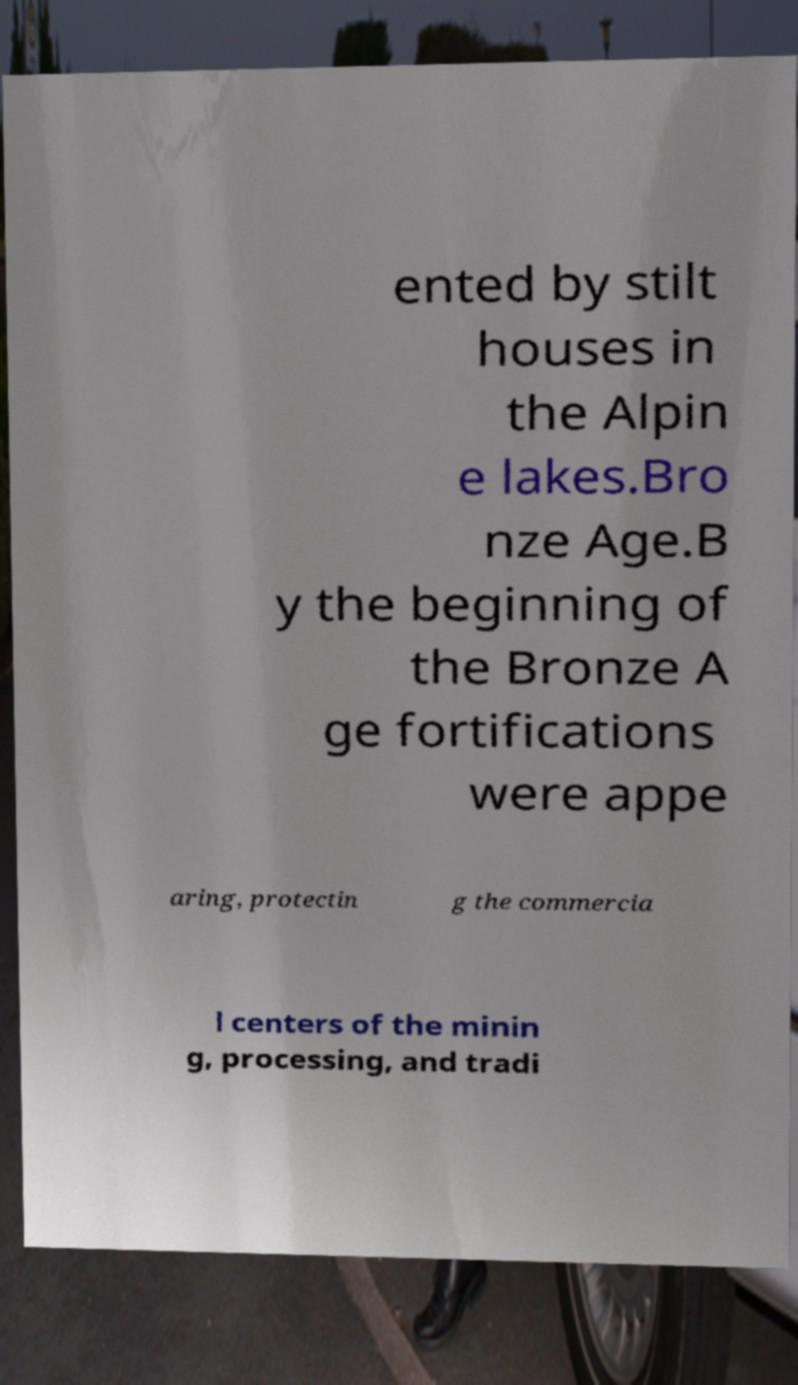Please identify and transcribe the text found in this image. ented by stilt houses in the Alpin e lakes.Bro nze Age.B y the beginning of the Bronze A ge fortifications were appe aring, protectin g the commercia l centers of the minin g, processing, and tradi 